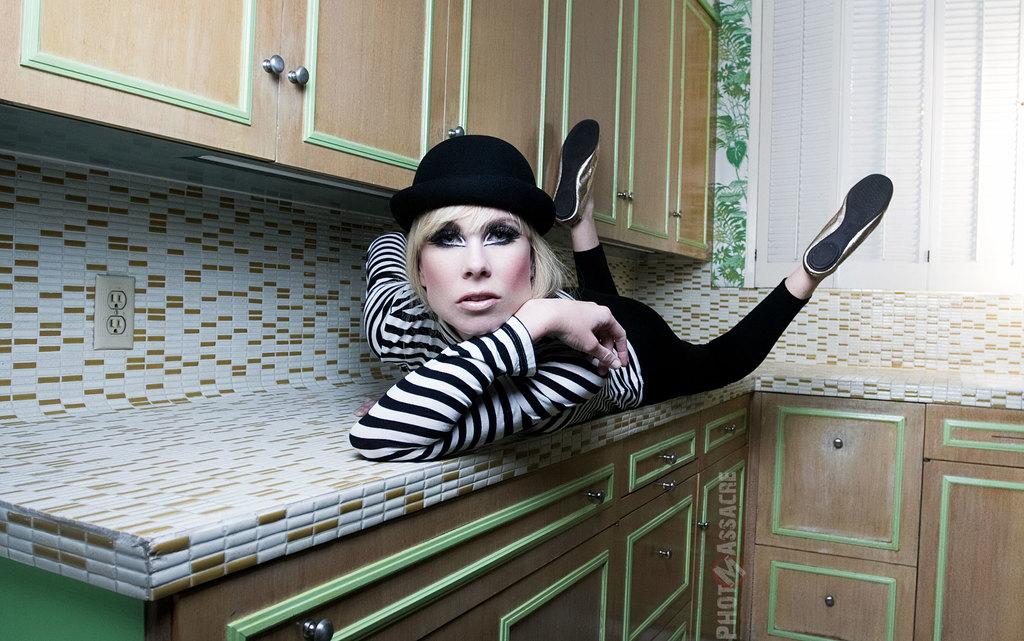Where is the image most likely taken? The image is likely taken inside a room. What is the woman doing in the image? The woman is lying on a table in the image. What can be seen in the background of the image? There are shelves and windows visible in the background of the image. Who is the owner of the print hanging on the wall in the image? There is no print hanging on the wall in the image. Can you see a swing in the image? No, there is no swing present in the image. 